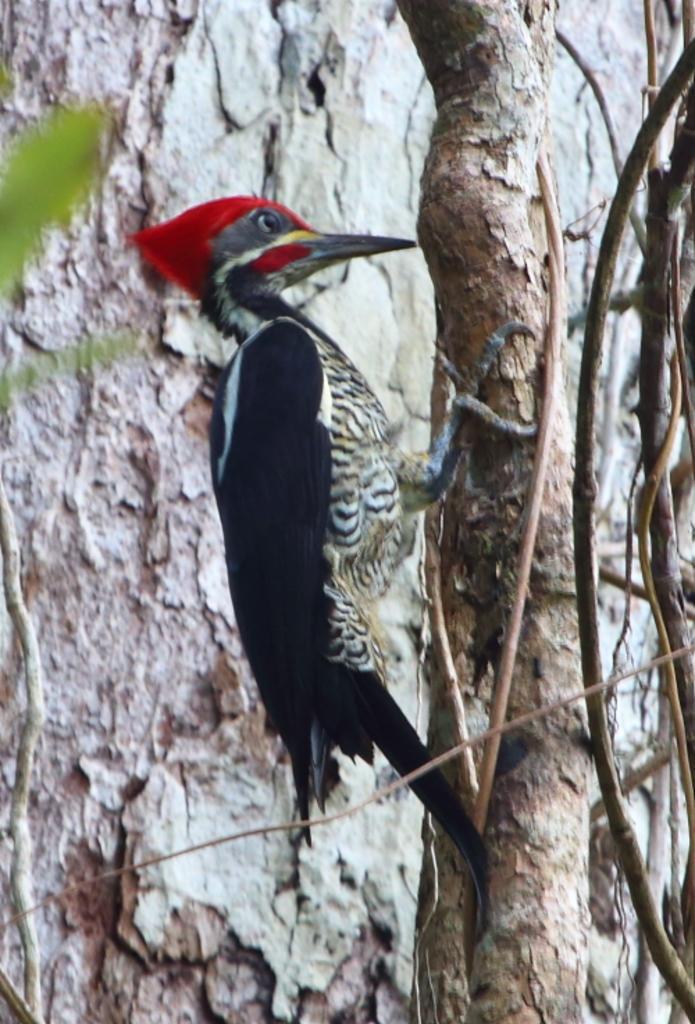Describe this image in one or two sentences. In this image we can see a bird on a tree. Behind the bird we can see the trunk of the tree. On the left side, we can see few leaves. 